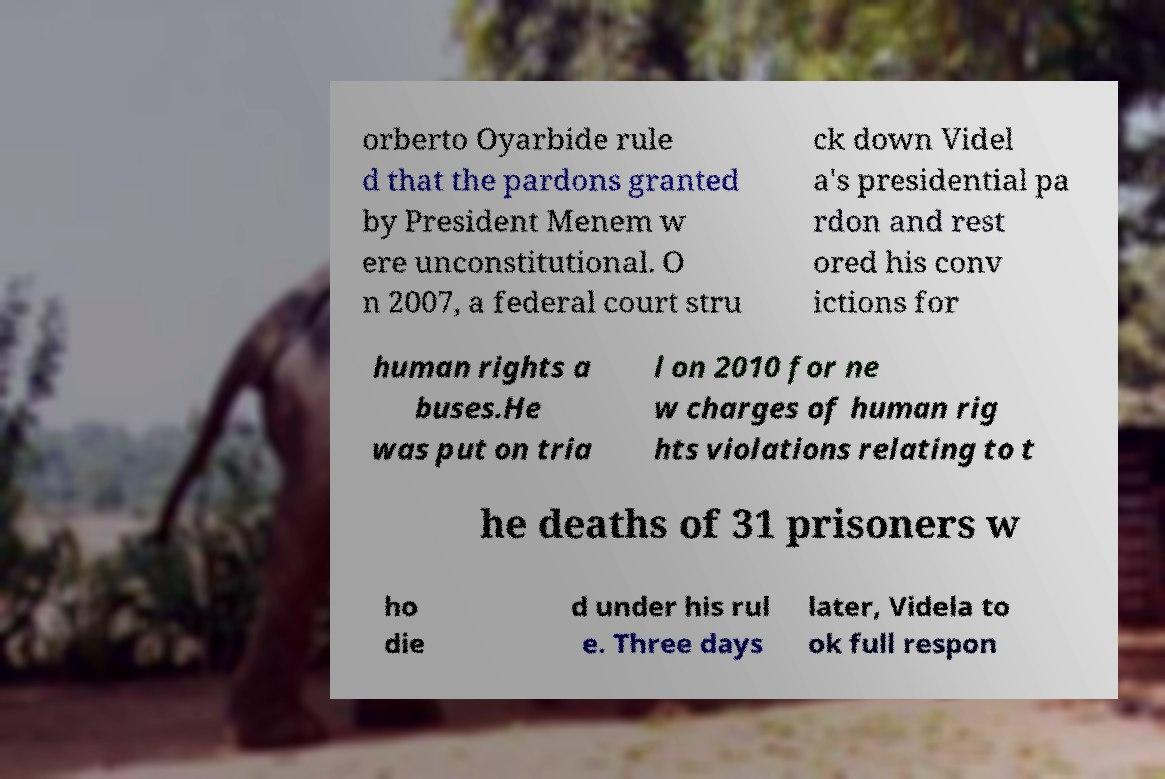Could you extract and type out the text from this image? orberto Oyarbide rule d that the pardons granted by President Menem w ere unconstitutional. O n 2007, a federal court stru ck down Videl a's presidential pa rdon and rest ored his conv ictions for human rights a buses.He was put on tria l on 2010 for ne w charges of human rig hts violations relating to t he deaths of 31 prisoners w ho die d under his rul e. Three days later, Videla to ok full respon 